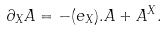Convert formula to latex. <formula><loc_0><loc_0><loc_500><loc_500>\partial _ { X } A = - ( e _ { X } ) . A + A ^ { X } .</formula> 